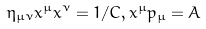Convert formula to latex. <formula><loc_0><loc_0><loc_500><loc_500>\eta _ { \mu \nu } x ^ { \mu } x ^ { \nu } = 1 / C , x ^ { \mu } p _ { \mu } = A</formula> 